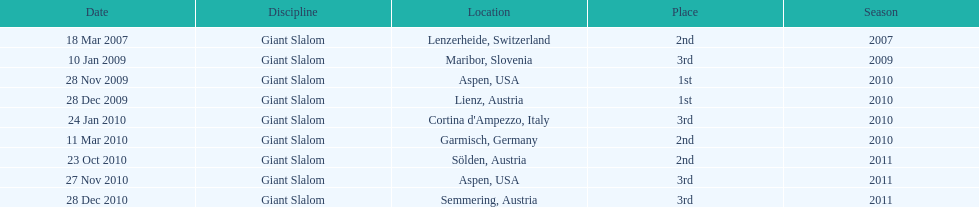Aspen and lienz in 2009 are the only races where this racer got what position? 1st. 